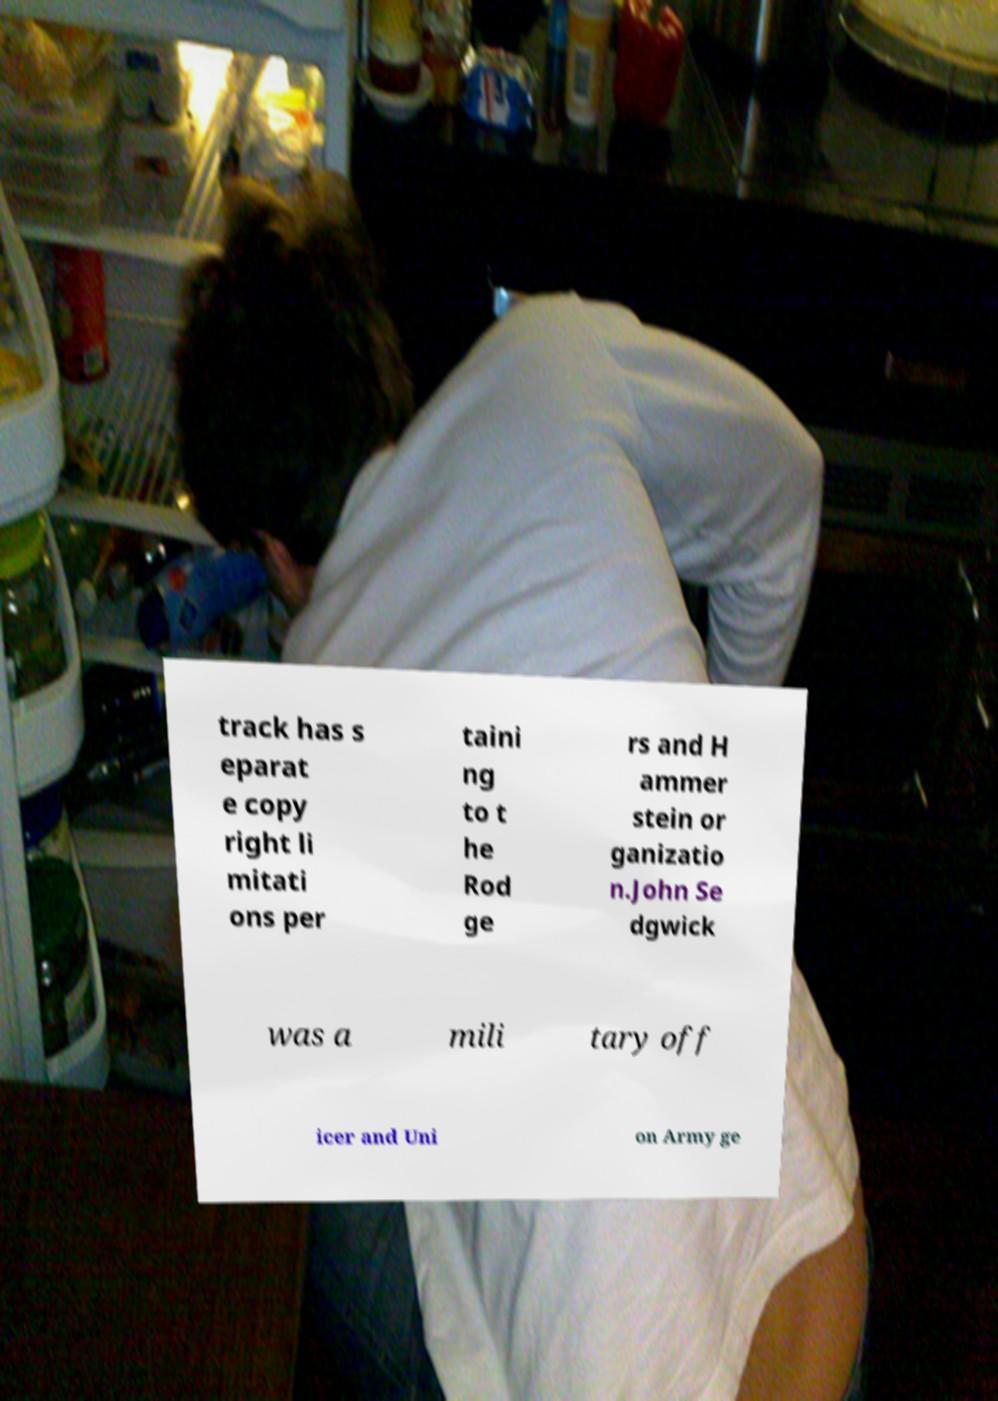Could you assist in decoding the text presented in this image and type it out clearly? track has s eparat e copy right li mitati ons per taini ng to t he Rod ge rs and H ammer stein or ganizatio n.John Se dgwick was a mili tary off icer and Uni on Army ge 